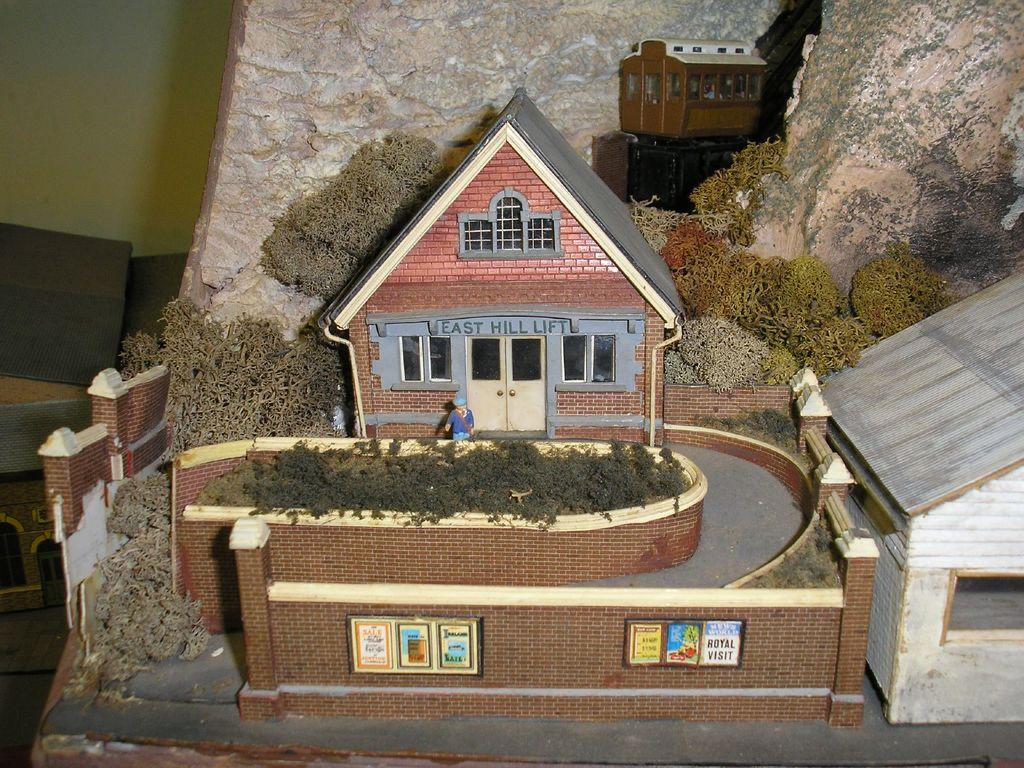What type of toys are present in the image? There are toy houses, a toy person, toy trees, a toy train, and a toy cave in the image. Can you describe the setting in which the toys are placed? The ground is visible in the image, and there is a wall present. What might be the purpose of the toy train in the image? The toy train could be used for transportation or play within the toy environment. How many pages are visible in the image? There are no pages present in the image; it features various toy items. Is there a wristwatch visible on the toy person in the image? There is no wristwatch visible on the toy person in the image. 